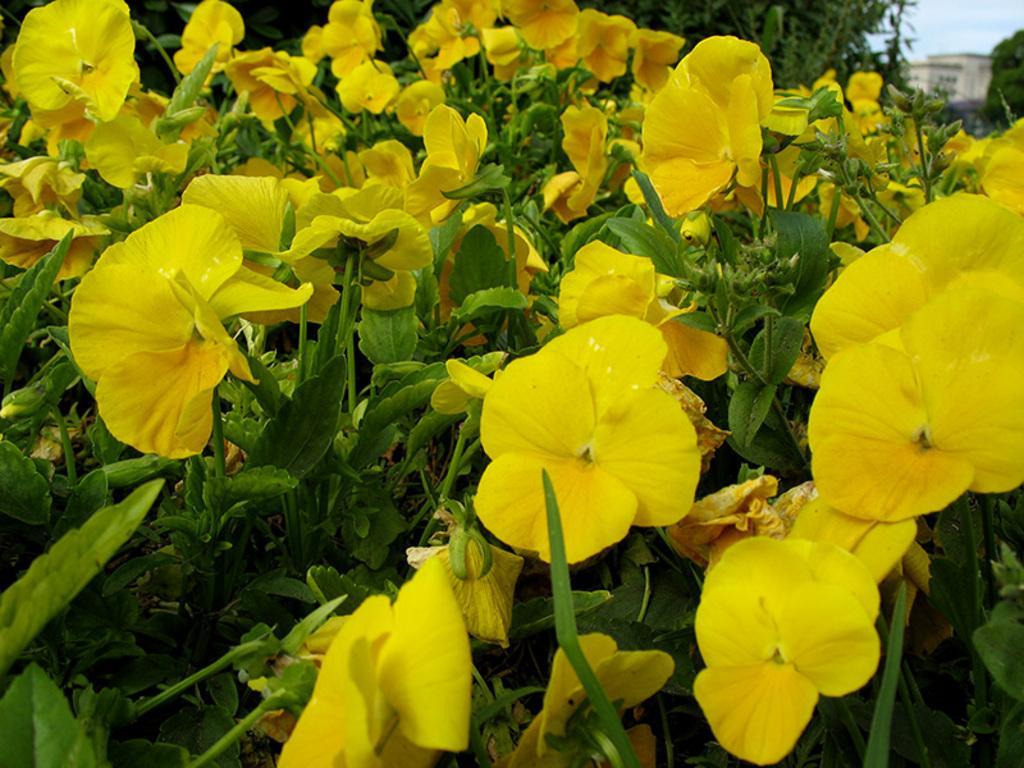How would you summarize this image in a sentence or two? In this picture we can see flowers and plants. In the background of the image it is blurry and we can see the sky. 